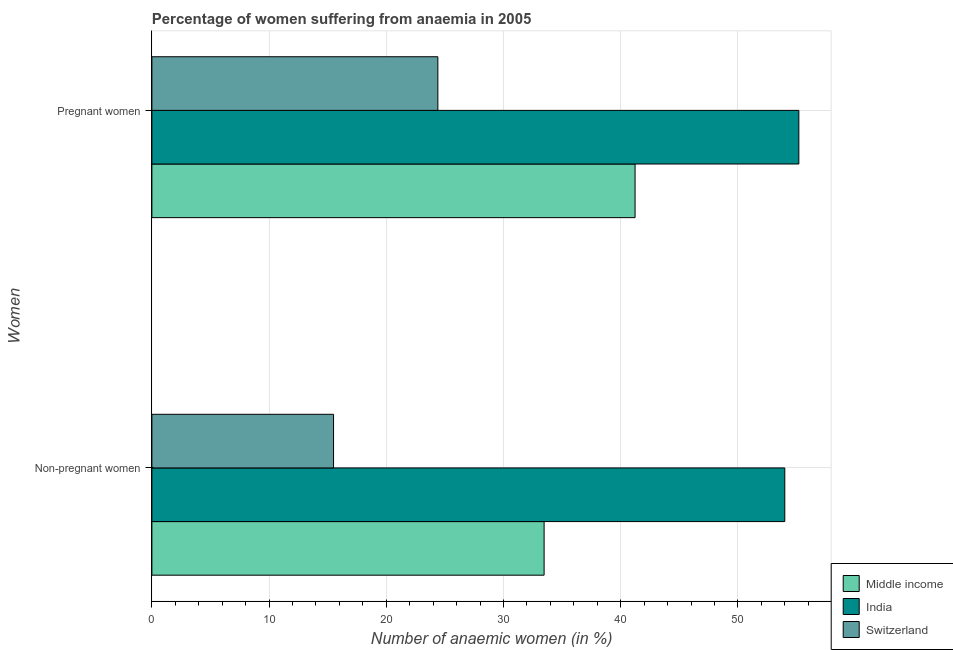How many groups of bars are there?
Keep it short and to the point. 2. Are the number of bars on each tick of the Y-axis equal?
Your response must be concise. Yes. How many bars are there on the 2nd tick from the top?
Offer a terse response. 3. How many bars are there on the 2nd tick from the bottom?
Your answer should be compact. 3. What is the label of the 2nd group of bars from the top?
Your response must be concise. Non-pregnant women. Across all countries, what is the minimum percentage of non-pregnant anaemic women?
Your response must be concise. 15.5. In which country was the percentage of non-pregnant anaemic women minimum?
Offer a terse response. Switzerland. What is the total percentage of pregnant anaemic women in the graph?
Ensure brevity in your answer.  120.83. What is the difference between the percentage of pregnant anaemic women in Middle income and that in Switzerland?
Give a very brief answer. 16.83. What is the difference between the percentage of non-pregnant anaemic women in Switzerland and the percentage of pregnant anaemic women in Middle income?
Provide a short and direct response. -25.73. What is the average percentage of non-pregnant anaemic women per country?
Provide a succinct answer. 34.32. What is the difference between the percentage of non-pregnant anaemic women and percentage of pregnant anaemic women in Middle income?
Provide a short and direct response. -7.76. What is the ratio of the percentage of non-pregnant anaemic women in Middle income to that in India?
Your answer should be compact. 0.62. Is the percentage of non-pregnant anaemic women in Middle income less than that in Switzerland?
Your answer should be compact. No. What does the 3rd bar from the bottom in Non-pregnant women represents?
Provide a short and direct response. Switzerland. How many bars are there?
Provide a succinct answer. 6. Are all the bars in the graph horizontal?
Your response must be concise. Yes. How many countries are there in the graph?
Provide a succinct answer. 3. What is the difference between two consecutive major ticks on the X-axis?
Ensure brevity in your answer.  10. Are the values on the major ticks of X-axis written in scientific E-notation?
Offer a terse response. No. How many legend labels are there?
Offer a terse response. 3. How are the legend labels stacked?
Ensure brevity in your answer.  Vertical. What is the title of the graph?
Give a very brief answer. Percentage of women suffering from anaemia in 2005. What is the label or title of the X-axis?
Your response must be concise. Number of anaemic women (in %). What is the label or title of the Y-axis?
Offer a very short reply. Women. What is the Number of anaemic women (in %) in Middle income in Non-pregnant women?
Keep it short and to the point. 33.47. What is the Number of anaemic women (in %) of Switzerland in Non-pregnant women?
Your response must be concise. 15.5. What is the Number of anaemic women (in %) of Middle income in Pregnant women?
Your answer should be very brief. 41.23. What is the Number of anaemic women (in %) in India in Pregnant women?
Your response must be concise. 55.2. What is the Number of anaemic women (in %) in Switzerland in Pregnant women?
Your answer should be very brief. 24.4. Across all Women, what is the maximum Number of anaemic women (in %) of Middle income?
Your answer should be compact. 41.23. Across all Women, what is the maximum Number of anaemic women (in %) in India?
Ensure brevity in your answer.  55.2. Across all Women, what is the maximum Number of anaemic women (in %) of Switzerland?
Offer a very short reply. 24.4. Across all Women, what is the minimum Number of anaemic women (in %) of Middle income?
Offer a very short reply. 33.47. What is the total Number of anaemic women (in %) in Middle income in the graph?
Offer a terse response. 74.69. What is the total Number of anaemic women (in %) of India in the graph?
Your response must be concise. 109.2. What is the total Number of anaemic women (in %) in Switzerland in the graph?
Keep it short and to the point. 39.9. What is the difference between the Number of anaemic women (in %) of Middle income in Non-pregnant women and that in Pregnant women?
Ensure brevity in your answer.  -7.76. What is the difference between the Number of anaemic women (in %) of India in Non-pregnant women and that in Pregnant women?
Offer a terse response. -1.2. What is the difference between the Number of anaemic women (in %) of Switzerland in Non-pregnant women and that in Pregnant women?
Your answer should be very brief. -8.9. What is the difference between the Number of anaemic women (in %) in Middle income in Non-pregnant women and the Number of anaemic women (in %) in India in Pregnant women?
Make the answer very short. -21.73. What is the difference between the Number of anaemic women (in %) of Middle income in Non-pregnant women and the Number of anaemic women (in %) of Switzerland in Pregnant women?
Make the answer very short. 9.06. What is the difference between the Number of anaemic women (in %) in India in Non-pregnant women and the Number of anaemic women (in %) in Switzerland in Pregnant women?
Offer a terse response. 29.6. What is the average Number of anaemic women (in %) in Middle income per Women?
Offer a terse response. 37.35. What is the average Number of anaemic women (in %) in India per Women?
Offer a terse response. 54.6. What is the average Number of anaemic women (in %) of Switzerland per Women?
Your response must be concise. 19.95. What is the difference between the Number of anaemic women (in %) in Middle income and Number of anaemic women (in %) in India in Non-pregnant women?
Give a very brief answer. -20.54. What is the difference between the Number of anaemic women (in %) in Middle income and Number of anaemic women (in %) in Switzerland in Non-pregnant women?
Ensure brevity in your answer.  17.96. What is the difference between the Number of anaemic women (in %) of India and Number of anaemic women (in %) of Switzerland in Non-pregnant women?
Give a very brief answer. 38.5. What is the difference between the Number of anaemic women (in %) of Middle income and Number of anaemic women (in %) of India in Pregnant women?
Provide a short and direct response. -13.97. What is the difference between the Number of anaemic women (in %) of Middle income and Number of anaemic women (in %) of Switzerland in Pregnant women?
Offer a terse response. 16.83. What is the difference between the Number of anaemic women (in %) in India and Number of anaemic women (in %) in Switzerland in Pregnant women?
Provide a short and direct response. 30.8. What is the ratio of the Number of anaemic women (in %) in Middle income in Non-pregnant women to that in Pregnant women?
Offer a terse response. 0.81. What is the ratio of the Number of anaemic women (in %) in India in Non-pregnant women to that in Pregnant women?
Offer a terse response. 0.98. What is the ratio of the Number of anaemic women (in %) of Switzerland in Non-pregnant women to that in Pregnant women?
Your answer should be very brief. 0.64. What is the difference between the highest and the second highest Number of anaemic women (in %) of Middle income?
Your answer should be compact. 7.76. What is the difference between the highest and the lowest Number of anaemic women (in %) of Middle income?
Ensure brevity in your answer.  7.76. What is the difference between the highest and the lowest Number of anaemic women (in %) of India?
Your answer should be very brief. 1.2. 